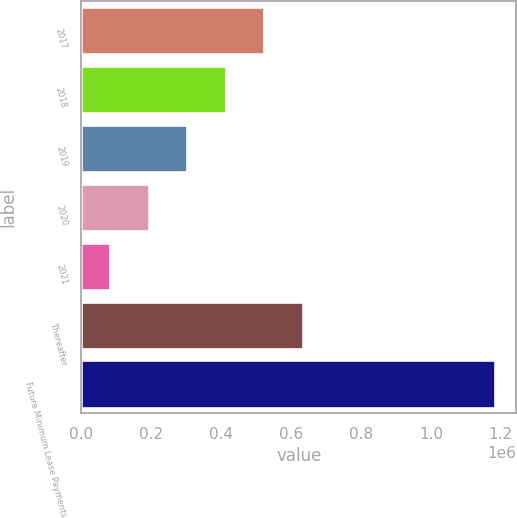Convert chart to OTSL. <chart><loc_0><loc_0><loc_500><loc_500><bar_chart><fcel>2017<fcel>2018<fcel>2019<fcel>2020<fcel>2021<fcel>Thereafter<fcel>Future Minimum Lease Payments<nl><fcel>523334<fcel>413124<fcel>302914<fcel>192704<fcel>82494<fcel>633544<fcel>1.18459e+06<nl></chart> 